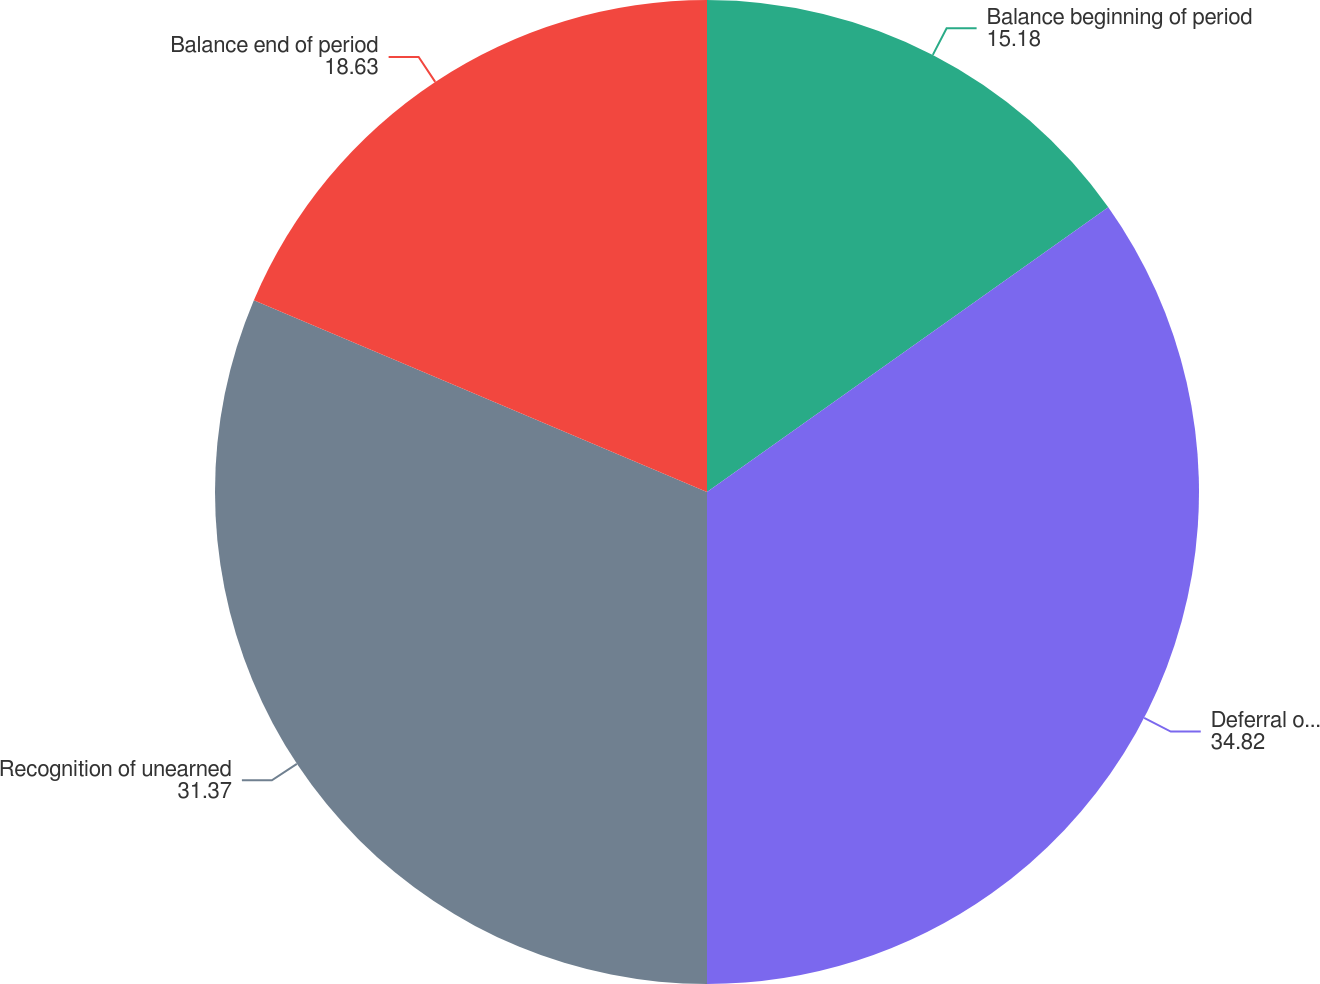Convert chart to OTSL. <chart><loc_0><loc_0><loc_500><loc_500><pie_chart><fcel>Balance beginning of period<fcel>Deferral of revenue<fcel>Recognition of unearned<fcel>Balance end of period<nl><fcel>15.18%<fcel>34.82%<fcel>31.37%<fcel>18.63%<nl></chart> 